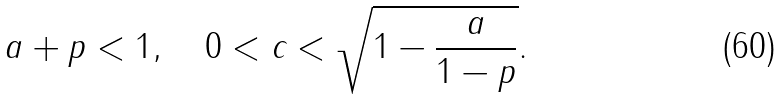<formula> <loc_0><loc_0><loc_500><loc_500>a + p < 1 , \quad 0 < c < \sqrt { 1 - \frac { a } { 1 - p } } .</formula> 